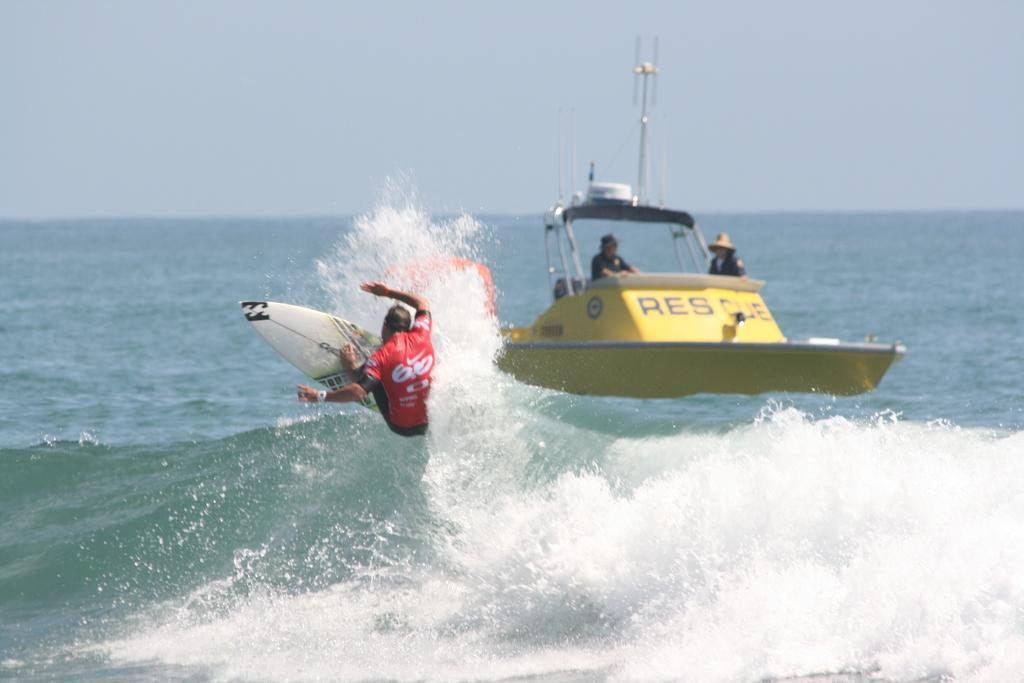<image>
Write a terse but informative summary of the picture. Rescue boat and a surfer outside in the water 